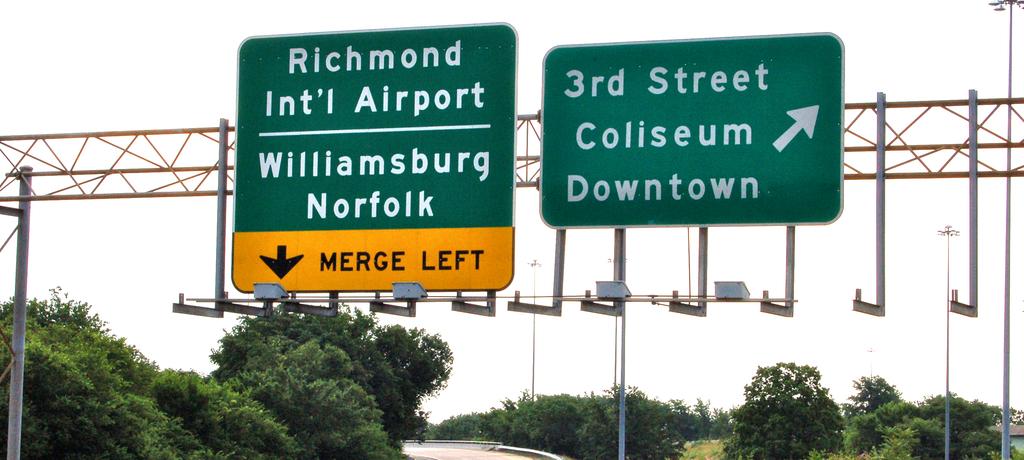What street to take to downtown?
Your answer should be very brief. 3rd street. 